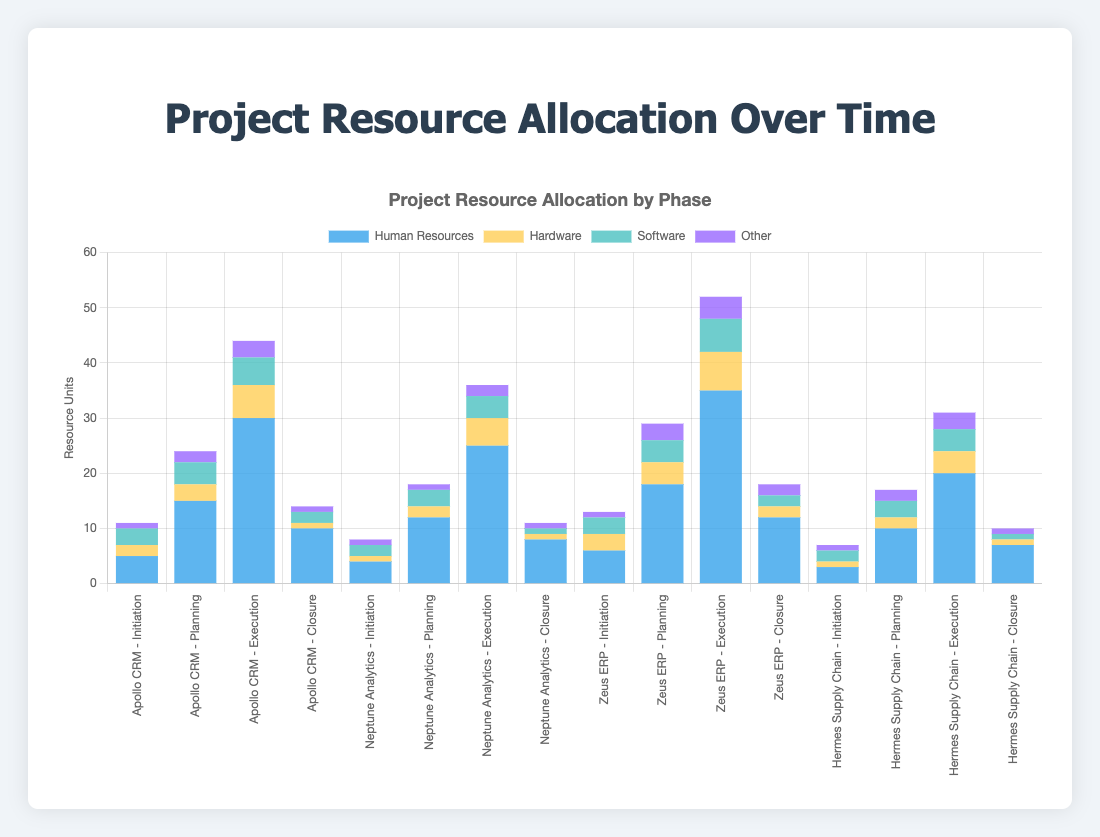What phase required the most hardware resources for Apollo CRM? To determine the phase with the most hardware resources for Apollo CRM, examine the heights of the hardware sections for each phase related to Apollo CRM. The Execution phase for Apollo CRM has the tallest hardware section.
Answer: Execution Compare the total human resources allocated in the Initiation phase across all projects. Which project required the most human resources? Sum up the human resources for the Initiation phase across all projects. The values are: Apollo CRM (5), Neptune Analytics (4), Zeus ERP (6), Hermes Supply Chain (3). Zeus ERP has the highest sum.
Answer: Zeus ERP By how much do the human resources allocated to the Planning phase of Zeus ERP exceed those of Hermes Supply Chain? Subtract the human resources for the Planning phase of Hermes Supply Chain (10) from those of Zeus ERP (18). The result is 18 - 10 = 8.
Answer: 8 Which project and phase combination shows the least amount of software resources allocated? Identify the project and phase with the smallest software section in the bar chart. The Closure phase of Neptune Analytics and Hermes Supply Chain both have the least software, each with a value of 1.
Answer: Closure phase of Neptune Analytics and Hermes Supply Chain What is the total resource allocation (sum of all resources) for the Execution phase of Neptune Analytics? Sum up all the resources for the Execution phase of Neptune Analytics: Human Resources (25), Hardware (5), Software (4), Other (2). The total is 25 + 5 + 4 + 2 = 36.
Answer: 36 How does the hardware allocation in the Closure phase of Zeus ERP compare to that in the Execution phase of Hermes Supply Chain? Compare the hardware allocations: Closure phase of Zeus ERP (2) vs. Execution phase of Hermes Supply Chain (4). The Execution phase of Hermes Supply Chain shows more hardware allocated.
Answer: Execution phase of Hermes Supply Chain has more In the Execution phase, which project has the highest software resource allocation, and what is the value? Look at the software sections of all bars in the Execution phase. The Zeus ERP project has the highest software allocation in the Execution phase with a value of 6.
Answer: Zeus ERP, 6 What percent of the total human resources allocated to the Planning phase across all projects went to Apollo CRM? First, calculate the total human resources allocated to the Planning phase across all projects: Apollo CRM (15), Neptune Analytics (12), Zeus ERP (18), Hermes Supply Chain (10). The total is 15 + 12 + 18 + 10 = 55. The percent for Apollo CRM is (15 / 55) * 100 = 27.27%.
Answer: 27.27% 